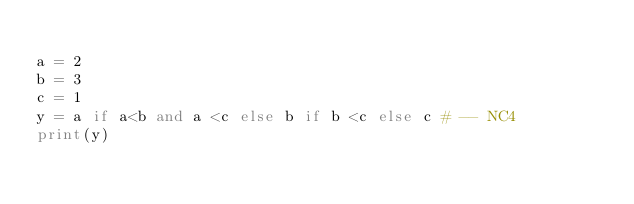Convert code to text. <code><loc_0><loc_0><loc_500><loc_500><_Python_>
a = 2
b = 3
c = 1
y = a if a<b and a <c else b if b <c else c # -- NC4
print(y)</code> 